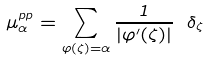<formula> <loc_0><loc_0><loc_500><loc_500>\mu _ { \alpha } ^ { p p } = \sum _ { \varphi ( \zeta ) = \alpha } \frac { 1 } { | \varphi ^ { \prime } ( \zeta ) | } \ \delta _ { \zeta }</formula> 